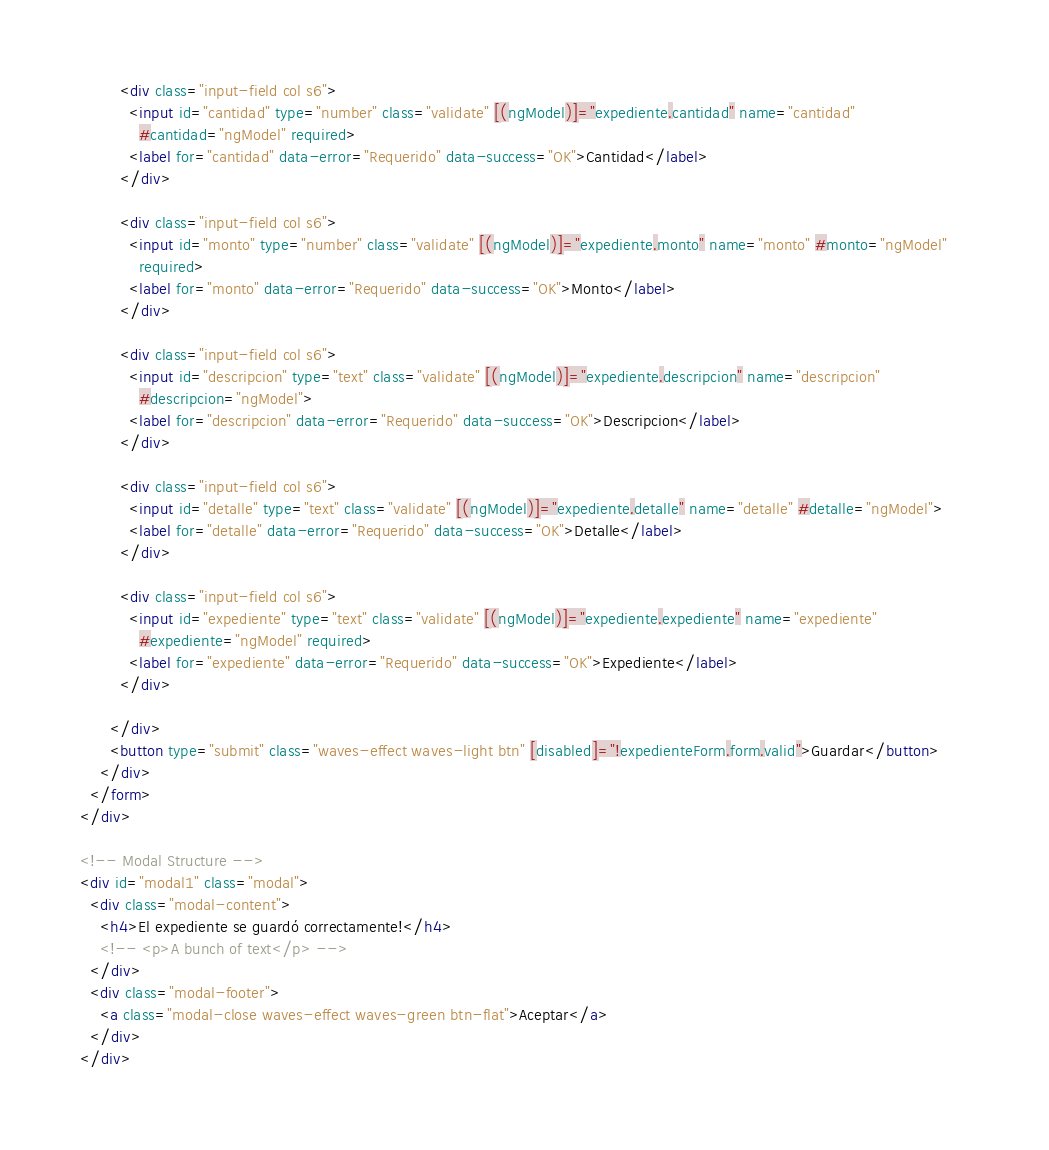Convert code to text. <code><loc_0><loc_0><loc_500><loc_500><_HTML_>
        <div class="input-field col s6">
          <input id="cantidad" type="number" class="validate" [(ngModel)]="expediente.cantidad" name="cantidad"
            #cantidad="ngModel" required>
          <label for="cantidad" data-error="Requerido" data-success="OK">Cantidad</label>
        </div>

        <div class="input-field col s6">
          <input id="monto" type="number" class="validate" [(ngModel)]="expediente.monto" name="monto" #monto="ngModel"
            required>
          <label for="monto" data-error="Requerido" data-success="OK">Monto</label>
        </div>

        <div class="input-field col s6">
          <input id="descripcion" type="text" class="validate" [(ngModel)]="expediente.descripcion" name="descripcion"
            #descripcion="ngModel">
          <label for="descripcion" data-error="Requerido" data-success="OK">Descripcion</label>
        </div>

        <div class="input-field col s6">
          <input id="detalle" type="text" class="validate" [(ngModel)]="expediente.detalle" name="detalle" #detalle="ngModel">
          <label for="detalle" data-error="Requerido" data-success="OK">Detalle</label>
        </div>

        <div class="input-field col s6">
          <input id="expediente" type="text" class="validate" [(ngModel)]="expediente.expediente" name="expediente"
            #expediente="ngModel" required>
          <label for="expediente" data-error="Requerido" data-success="OK">Expediente</label>
        </div>

      </div>
      <button type="submit" class="waves-effect waves-light btn" [disabled]="!expedienteForm.form.valid">Guardar</button>      
    </div>
  </form>
</div>

<!-- Modal Structure -->
<div id="modal1" class="modal">
  <div class="modal-content">
    <h4>El expediente se guardó correctamente!</h4>
    <!-- <p>A bunch of text</p> -->
  </div>
  <div class="modal-footer">
    <a class="modal-close waves-effect waves-green btn-flat">Aceptar</a>
  </div>
</div>
</code> 